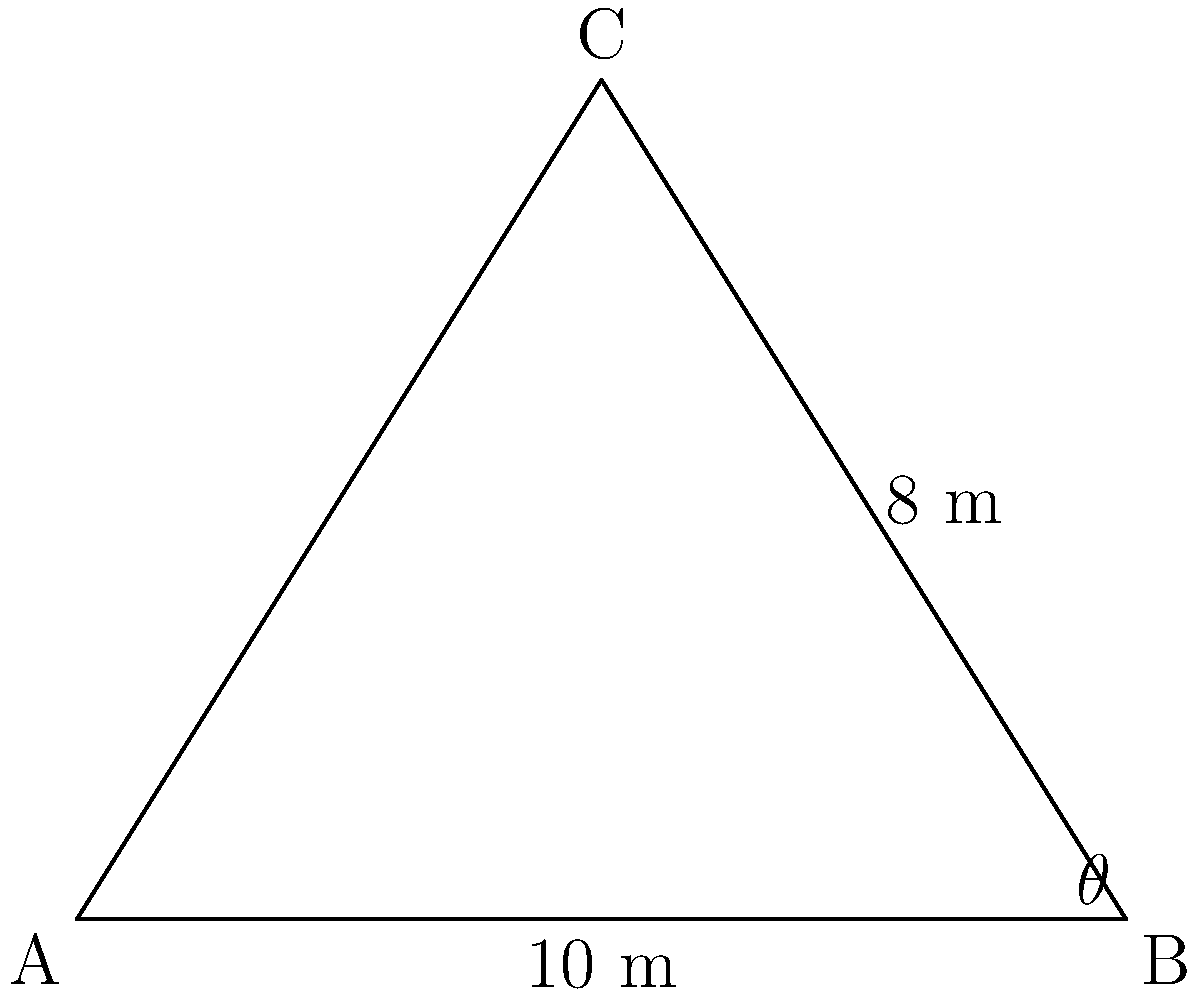You're designing a new triangular fishing net. The base of the net is 10 meters, and the perpendicular height from the base to the apex is 8 meters. What is the area of the fishing net when fully spread out? To find the area of the triangular fishing net, we can use the formula for the area of a triangle:

$$A = \frac{1}{2} \times base \times height$$

Given:
- Base of the triangle (fishing net) = 10 meters
- Height of the triangle = 8 meters

Let's substitute these values into the formula:

$$A = \frac{1}{2} \times 10 \times 8$$

Now, let's calculate:

$$A = \frac{1}{2} \times 80$$
$$A = 40$$

Therefore, the area of the fishing net when fully spread out is 40 square meters.
Answer: 40 m² 